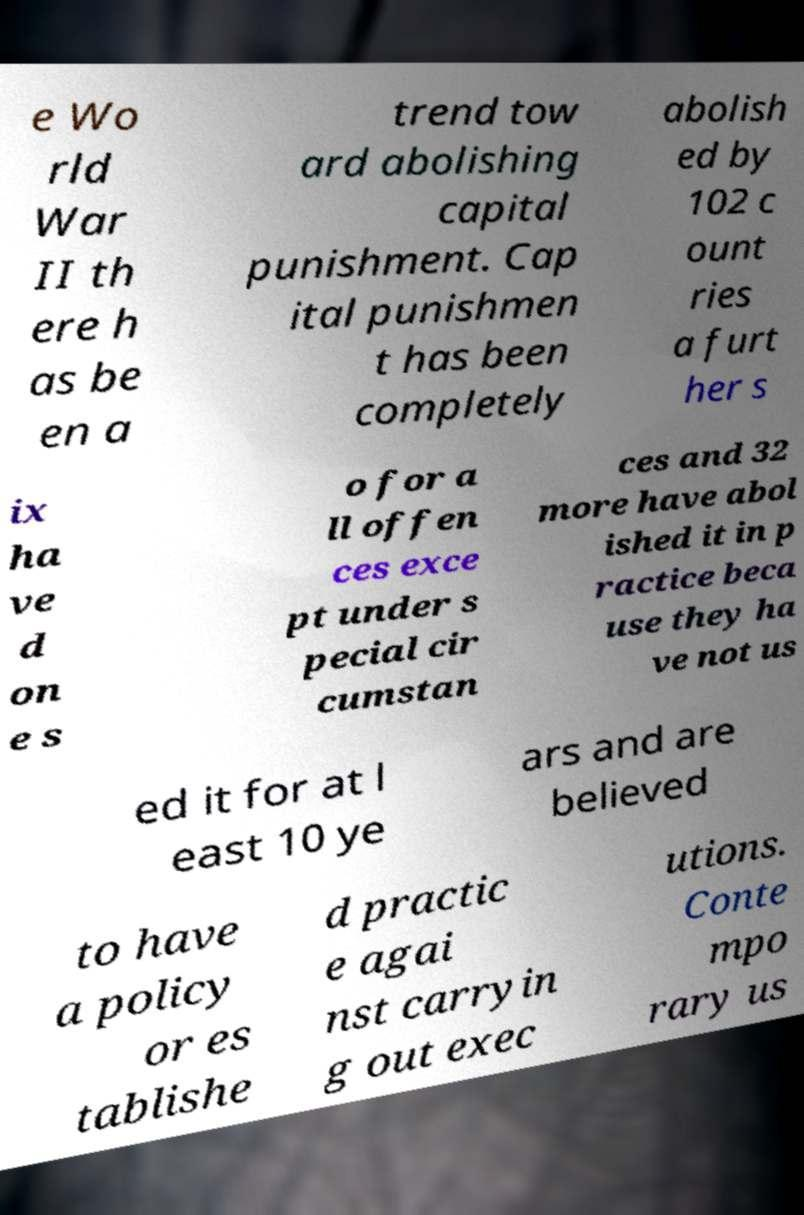Please read and relay the text visible in this image. What does it say? e Wo rld War II th ere h as be en a trend tow ard abolishing capital punishment. Cap ital punishmen t has been completely abolish ed by 102 c ount ries a furt her s ix ha ve d on e s o for a ll offen ces exce pt under s pecial cir cumstan ces and 32 more have abol ished it in p ractice beca use they ha ve not us ed it for at l east 10 ye ars and are believed to have a policy or es tablishe d practic e agai nst carryin g out exec utions. Conte mpo rary us 